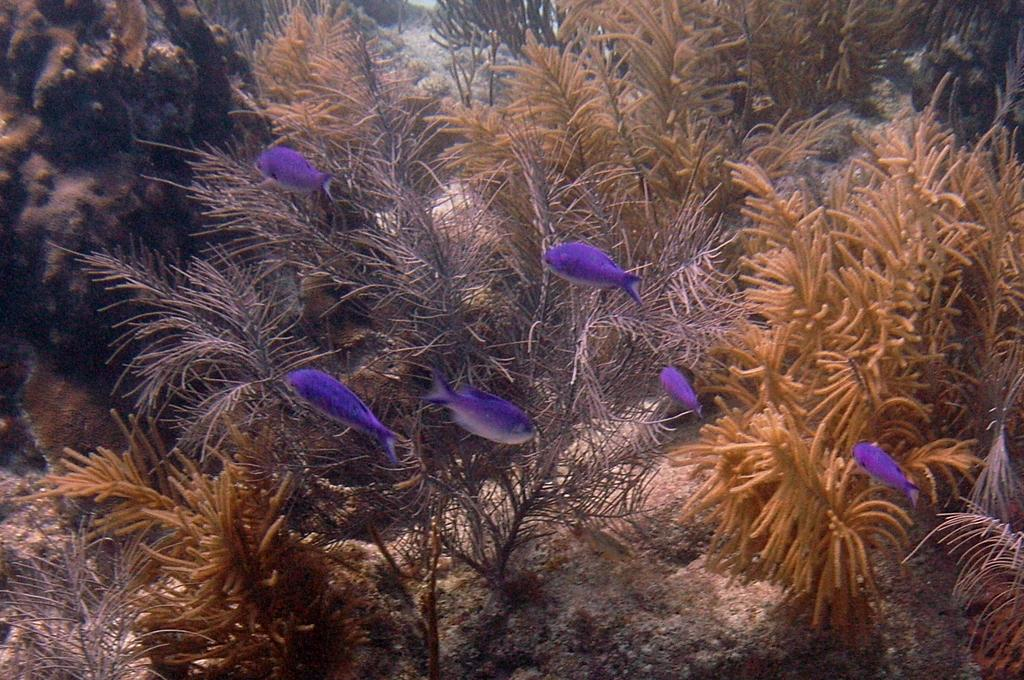What type of plants are in the image? There are water plants in the image. What animals can be seen in the image? There are fishes in the middle of the image. What type of leather material can be seen in the image? There is no leather material present in the image; it features water plants and fishes. What sound can be heard coming from the school in the image? There is no school or any sound in the image, as it only contains water plants and fishes. 